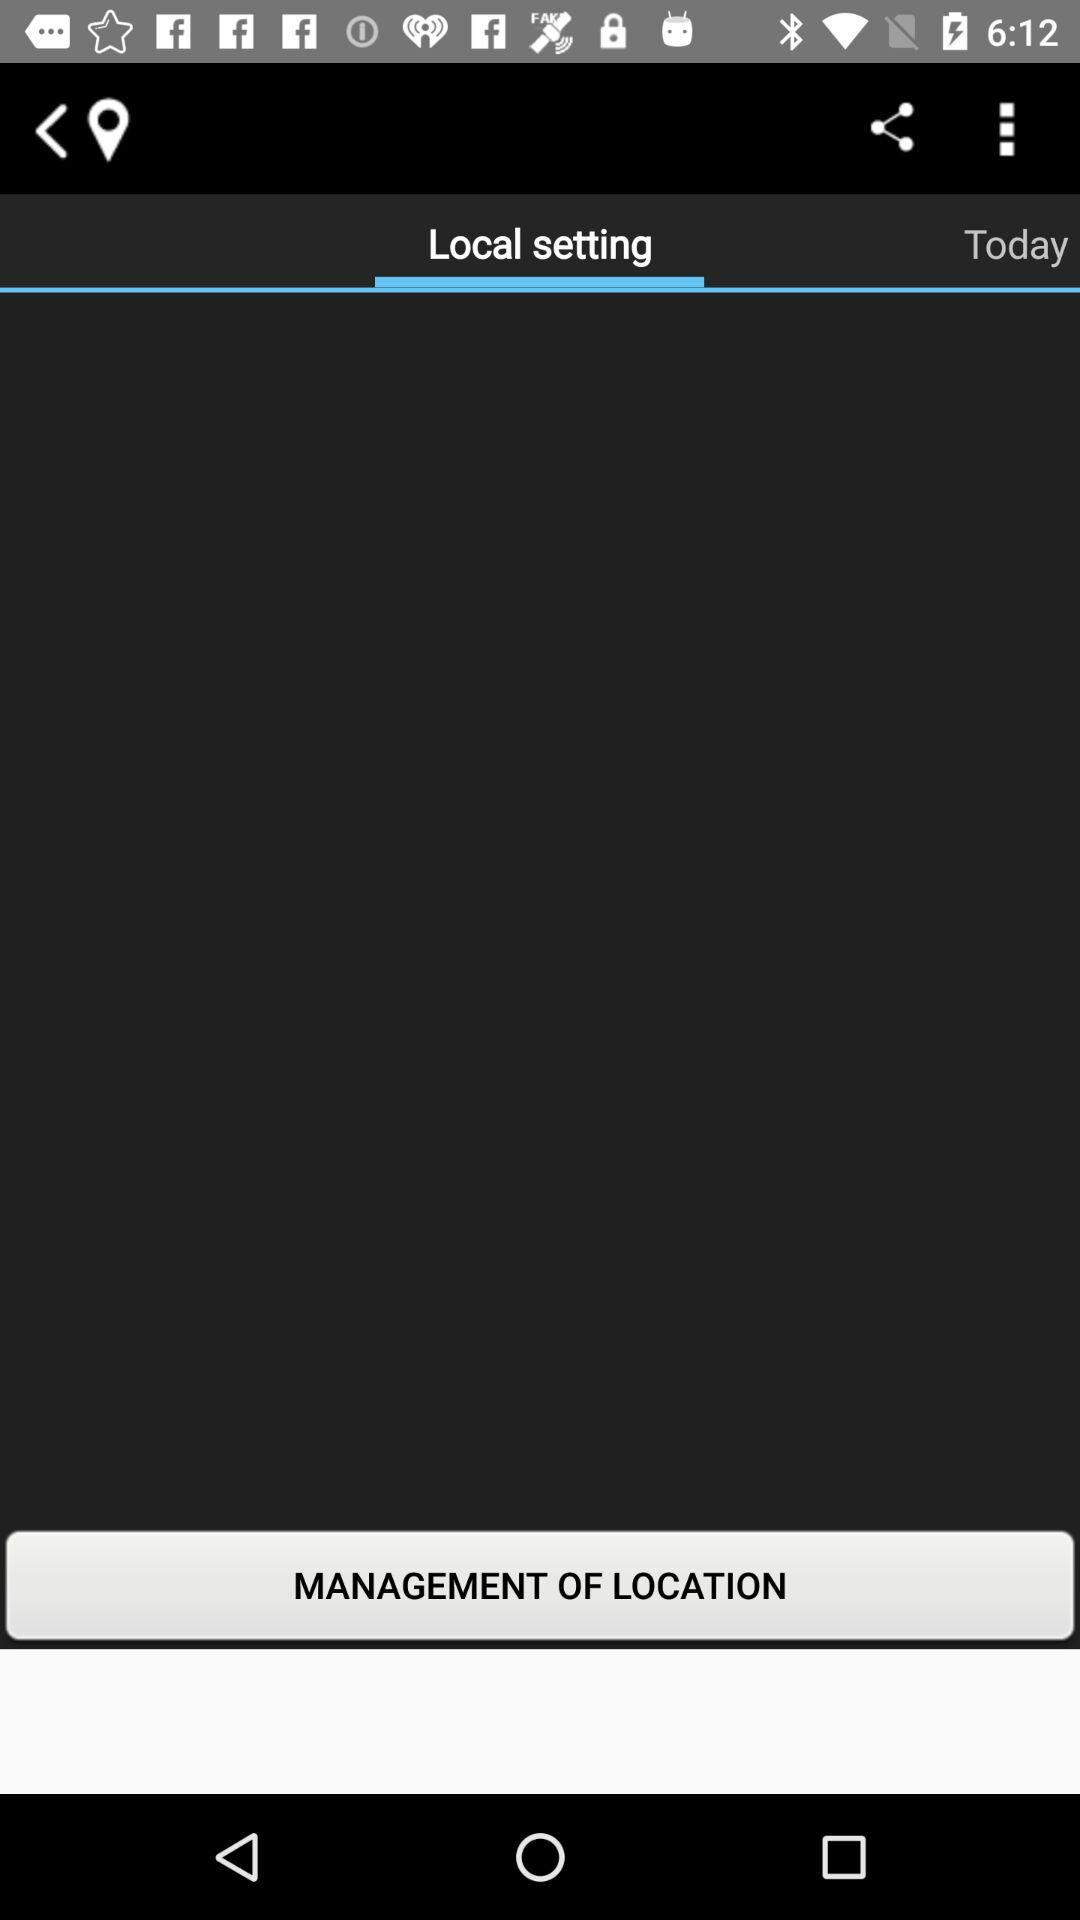Which tab is selected? The selected tab is "Local setting". 